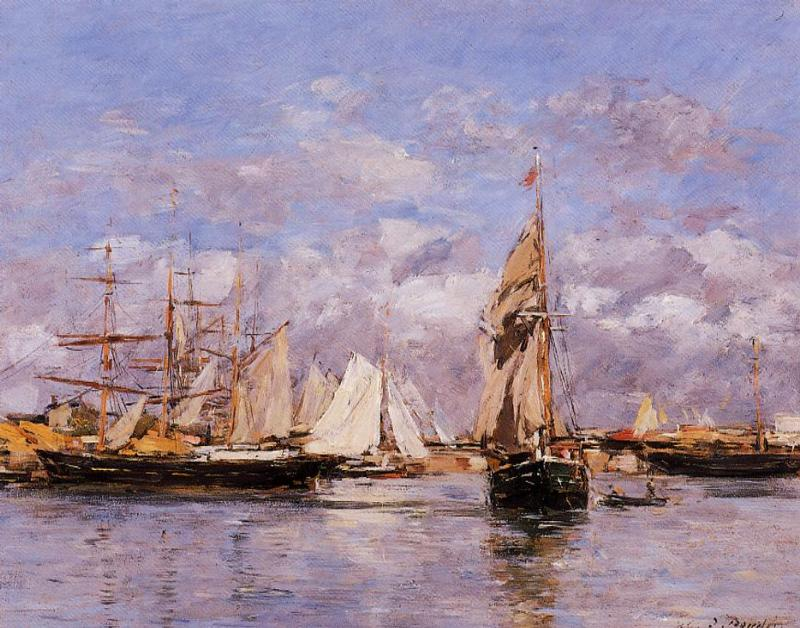How might the elements of this painting reflect the social or economic activities of the time? The variety of boats depicted in the harbor reflects a bustling maritime trade, with larger ships suggesting long-distance trade and smaller boats hinting at local commerce or leisure activities. The presence of multiple ships and their size can indicate economic prosperity and an active harbor important for trade. Furthermore, the buildings in the background suggest a thriving town or city nearby, implying a connection between the sea and urban development. The impressionist style, allowing the viewer to engage more personally with the scene, can also reflect the changing perceptions of the modernizing world during the time when impressionism was at its height. 